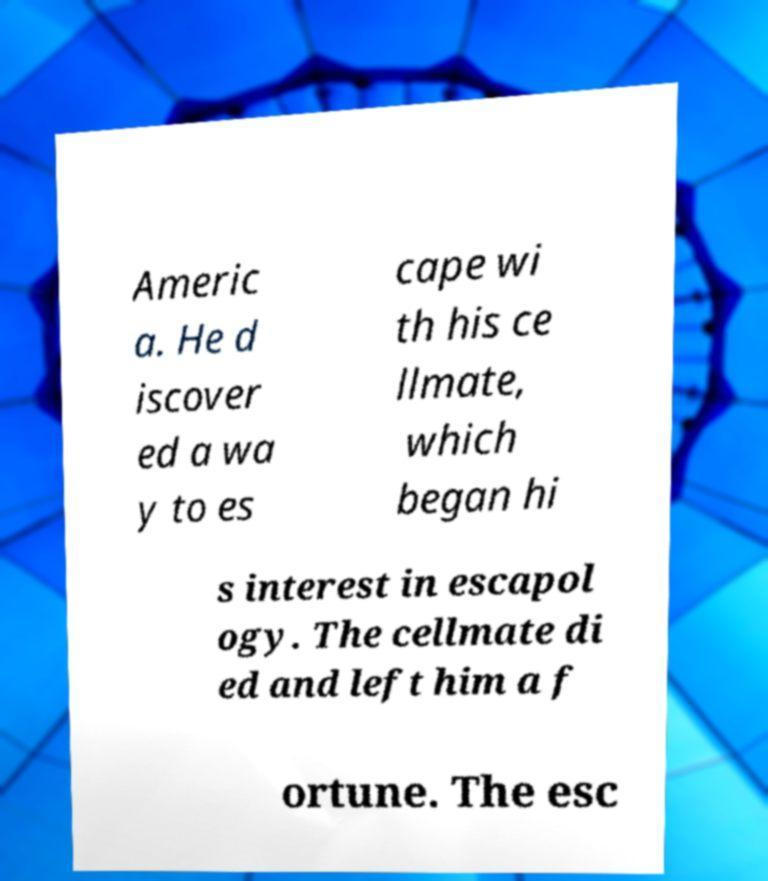Can you read and provide the text displayed in the image?This photo seems to have some interesting text. Can you extract and type it out for me? Americ a. He d iscover ed a wa y to es cape wi th his ce llmate, which began hi s interest in escapol ogy. The cellmate di ed and left him a f ortune. The esc 